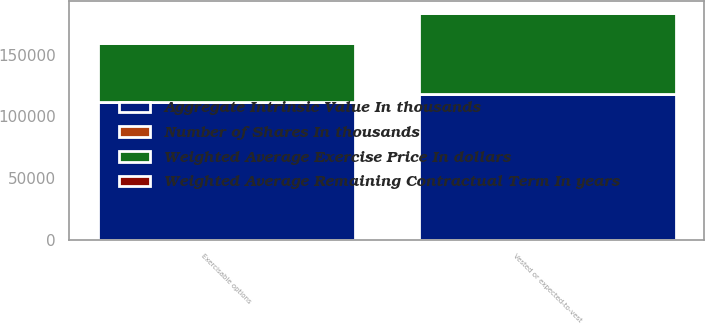Convert chart to OTSL. <chart><loc_0><loc_0><loc_500><loc_500><stacked_bar_chart><ecel><fcel>Vested or expected-to-vest<fcel>Exercisable options<nl><fcel>Weighted Average Exercise Price In dollars<fcel>65499<fcel>47176<nl><fcel>Number of Shares In thousands<fcel>21.13<fcel>20.59<nl><fcel>Weighted Average Remaining Contractual Term In years<fcel>4.8<fcel>4.4<nl><fcel>Aggregate Intrinsic Value In thousands<fcel>118512<fcel>111975<nl></chart> 